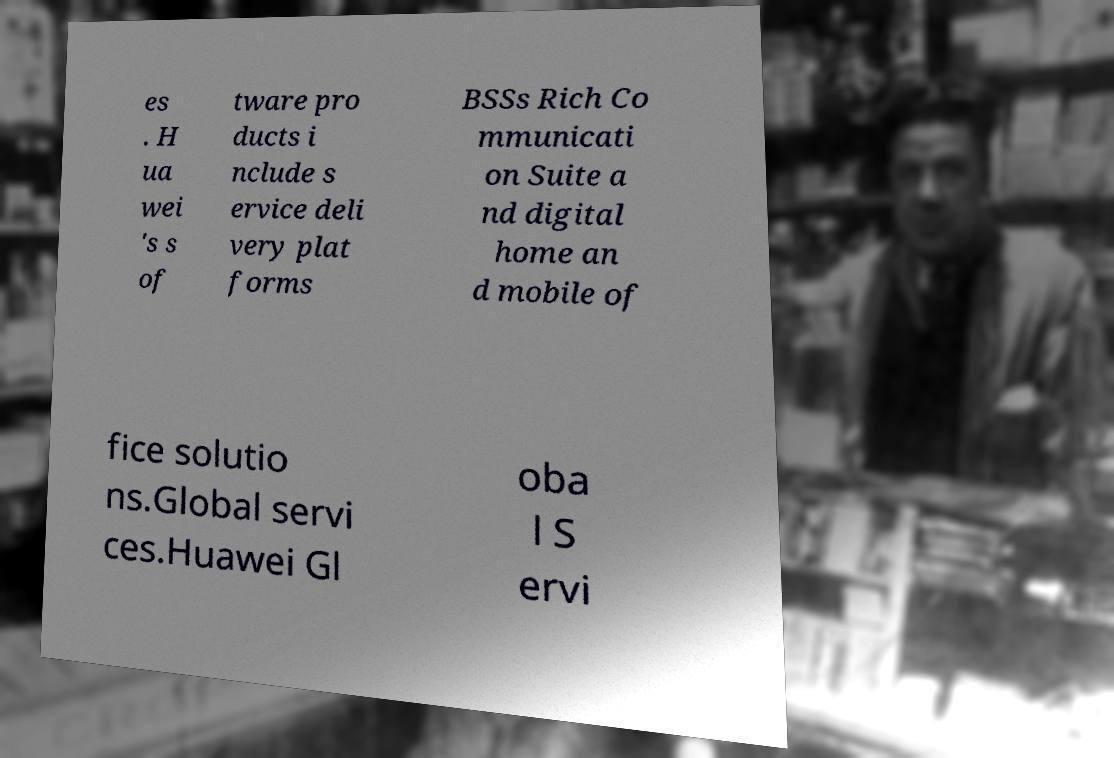Could you assist in decoding the text presented in this image and type it out clearly? es . H ua wei 's s of tware pro ducts i nclude s ervice deli very plat forms BSSs Rich Co mmunicati on Suite a nd digital home an d mobile of fice solutio ns.Global servi ces.Huawei Gl oba l S ervi 